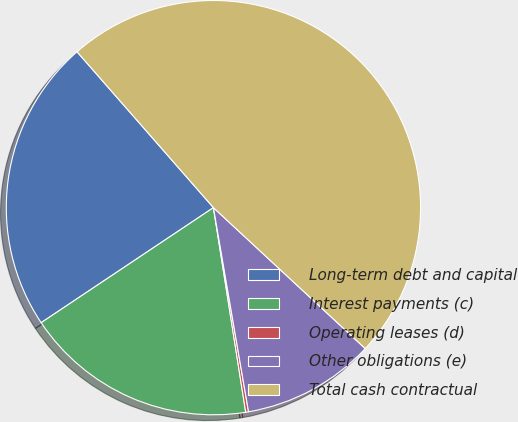<chart> <loc_0><loc_0><loc_500><loc_500><pie_chart><fcel>Long-term debt and capital<fcel>Interest payments (c)<fcel>Operating leases (d)<fcel>Other obligations (e)<fcel>Total cash contractual<nl><fcel>22.93%<fcel>18.12%<fcel>0.22%<fcel>10.38%<fcel>48.35%<nl></chart> 